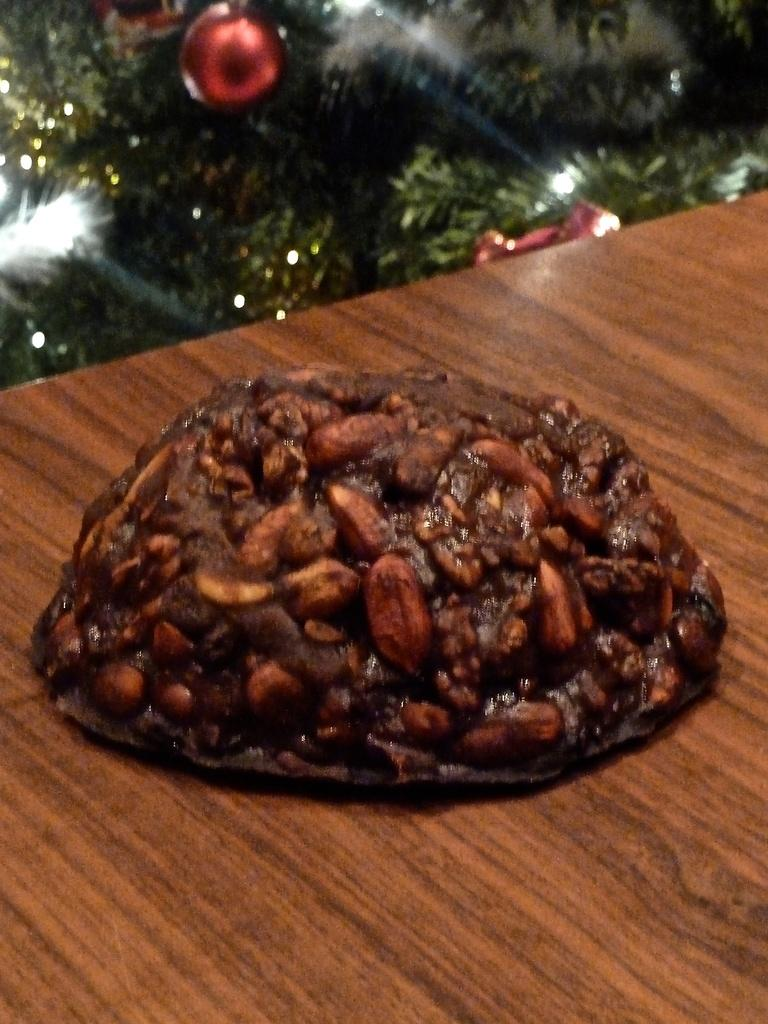What is on the table in the image? There is food on the table in the image. What can be seen in the background of the image? There is a Christmas tree in the background of the image. Are there any decorations on the Christmas tree? Yes, there is a ball on the Christmas tree. How many icicles are hanging from the table in the image? There are no icicles hanging from the table in the image. Can you see any rabbits near the Christmas tree in the image? There are no rabbits present in the image. 